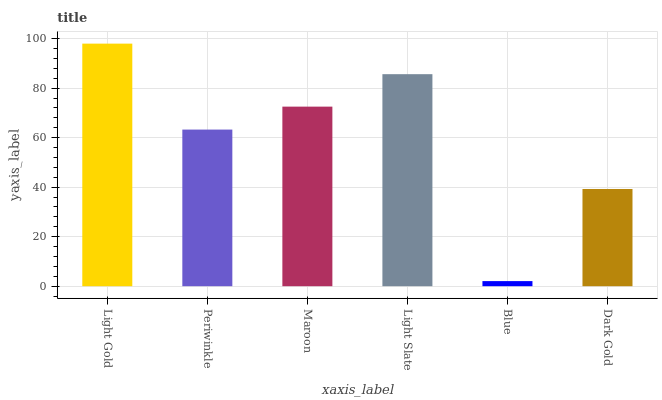Is Blue the minimum?
Answer yes or no. Yes. Is Light Gold the maximum?
Answer yes or no. Yes. Is Periwinkle the minimum?
Answer yes or no. No. Is Periwinkle the maximum?
Answer yes or no. No. Is Light Gold greater than Periwinkle?
Answer yes or no. Yes. Is Periwinkle less than Light Gold?
Answer yes or no. Yes. Is Periwinkle greater than Light Gold?
Answer yes or no. No. Is Light Gold less than Periwinkle?
Answer yes or no. No. Is Maroon the high median?
Answer yes or no. Yes. Is Periwinkle the low median?
Answer yes or no. Yes. Is Dark Gold the high median?
Answer yes or no. No. Is Light Gold the low median?
Answer yes or no. No. 